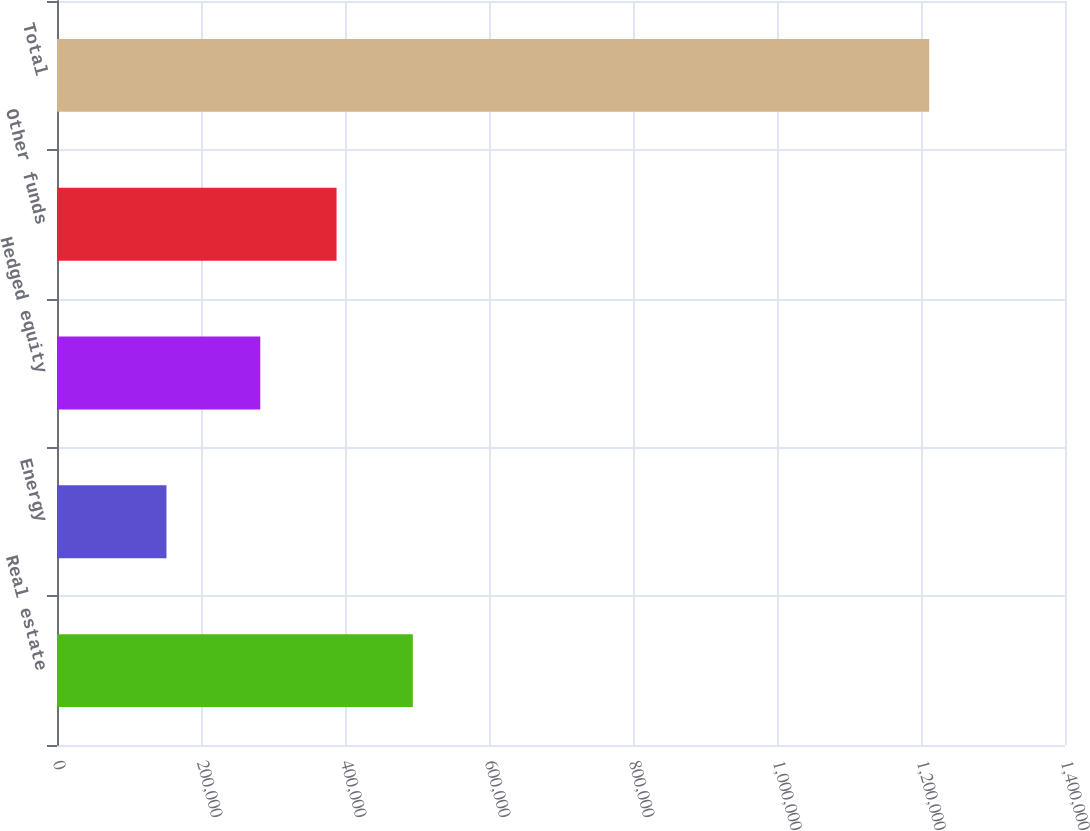Convert chart. <chart><loc_0><loc_0><loc_500><loc_500><bar_chart><fcel>Real estate<fcel>Energy<fcel>Hedged equity<fcel>Other funds<fcel>Total<nl><fcel>494204<fcel>152056<fcel>282335<fcel>388270<fcel>1.2114e+06<nl></chart> 